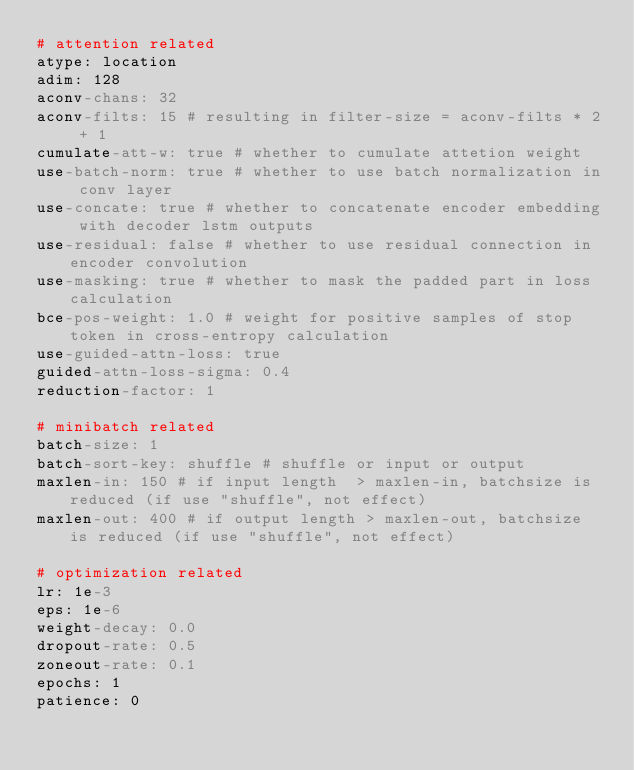<code> <loc_0><loc_0><loc_500><loc_500><_YAML_># attention related
atype: location
adim: 128
aconv-chans: 32
aconv-filts: 15 # resulting in filter-size = aconv-filts * 2 + 1
cumulate-att-w: true # whether to cumulate attetion weight
use-batch-norm: true # whether to use batch normalization in conv layer
use-concate: true # whether to concatenate encoder embedding with decoder lstm outputs
use-residual: false # whether to use residual connection in encoder convolution
use-masking: true # whether to mask the padded part in loss calculation
bce-pos-weight: 1.0 # weight for positive samples of stop token in cross-entropy calculation
use-guided-attn-loss: true
guided-attn-loss-sigma: 0.4
reduction-factor: 1

# minibatch related
batch-size: 1
batch-sort-key: shuffle # shuffle or input or output
maxlen-in: 150 # if input length  > maxlen-in, batchsize is reduced (if use "shuffle", not effect)
maxlen-out: 400 # if output length > maxlen-out, batchsize is reduced (if use "shuffle", not effect)

# optimization related
lr: 1e-3
eps: 1e-6
weight-decay: 0.0
dropout-rate: 0.5
zoneout-rate: 0.1
epochs: 1
patience: 0
</code> 